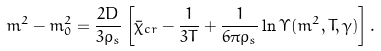<formula> <loc_0><loc_0><loc_500><loc_500>m ^ { 2 } - m _ { 0 } ^ { 2 } = \frac { 2 D } { 3 \rho _ { s } } \left [ \bar { \chi } _ { c r } - \frac { 1 } { 3 T } + \frac { 1 } { 6 \pi \rho _ { s } } \ln \Upsilon ( m ^ { 2 } , T , \gamma ) \right ] .</formula> 